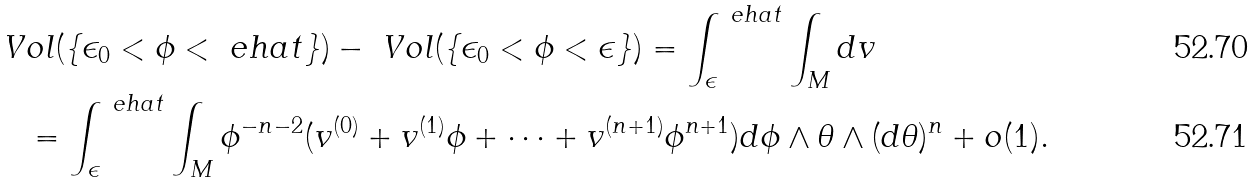<formula> <loc_0><loc_0><loc_500><loc_500>& \ V o l ( \{ \epsilon _ { 0 } < \phi < \ e h a t \} ) - \ V o l ( \{ \epsilon _ { 0 } < \phi < \epsilon \} ) = \int _ { \epsilon } ^ { \ e h a t } \int _ { M } d v \\ & \quad = \int _ { \epsilon } ^ { \ e h a t } \int _ { M } \phi ^ { - n - 2 } ( v ^ { ( 0 ) } + v ^ { ( 1 ) } \phi + \cdots + v ^ { ( n + 1 ) } \phi ^ { n + 1 } ) d \phi \wedge \theta \wedge ( d \theta ) ^ { n } + o ( 1 ) .</formula> 